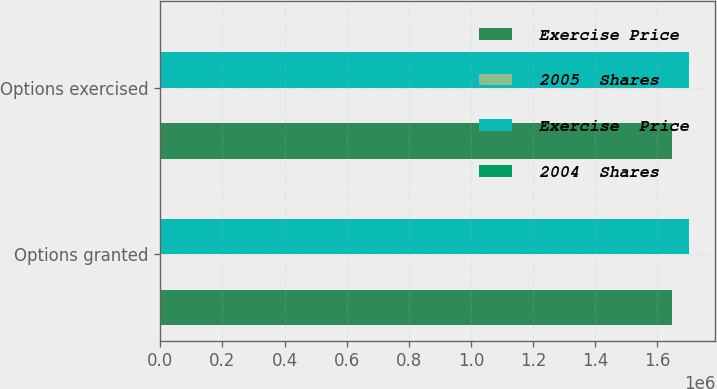<chart> <loc_0><loc_0><loc_500><loc_500><stacked_bar_chart><ecel><fcel>Options granted<fcel>Options exercised<nl><fcel>Exercise Price<fcel>1.64652e+06<fcel>1.64652e+06<nl><fcel>2005  Shares<fcel>66.11<fcel>66.11<nl><fcel>Exercise  Price<fcel>1.70187e+06<fcel>1.70187e+06<nl><fcel>2004  Shares<fcel>69.65<fcel>69.65<nl></chart> 